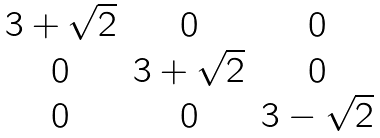<formula> <loc_0><loc_0><loc_500><loc_500>\begin{matrix} 3 + \sqrt { 2 } & 0 & 0 \\ 0 & 3 + \sqrt { 2 } & 0 \\ 0 & 0 & 3 - \sqrt { 2 } \end{matrix}</formula> 